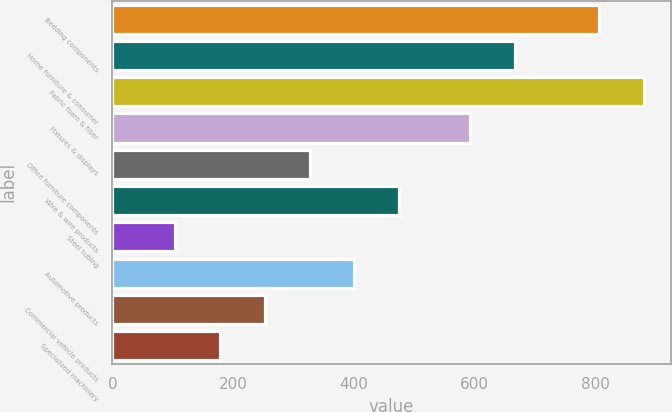Convert chart to OTSL. <chart><loc_0><loc_0><loc_500><loc_500><bar_chart><fcel>Bedding components<fcel>Home furniture & consumer<fcel>Fabric foam & fiber<fcel>Fixtures & displays<fcel>Office furniture components<fcel>Wire & wire products<fcel>Steel tubing<fcel>Automotive products<fcel>Commercial vehicle products<fcel>Specialized machinery<nl><fcel>806.6<fcel>667.34<fcel>880.84<fcel>593.1<fcel>326.82<fcel>475.3<fcel>104.1<fcel>401.06<fcel>252.58<fcel>178.34<nl></chart> 